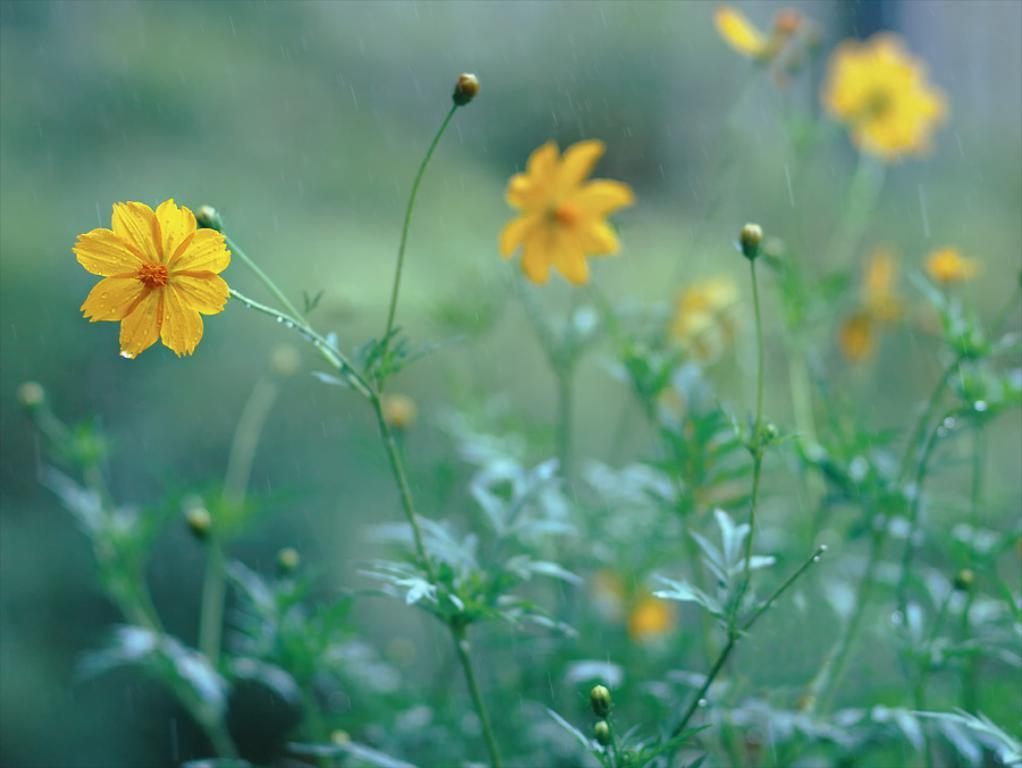What type of flowers can be seen in the image? There are yellow flowers in the image. What color are the leaves associated with the flowers? There are green leaves in the image. Can you describe the background of the image? The background is slightly blurry. What type of glass is being played by the musician in the middle of the image? There is no musician or glass present in the image; it features yellow flowers and green leaves with a blurry background. 